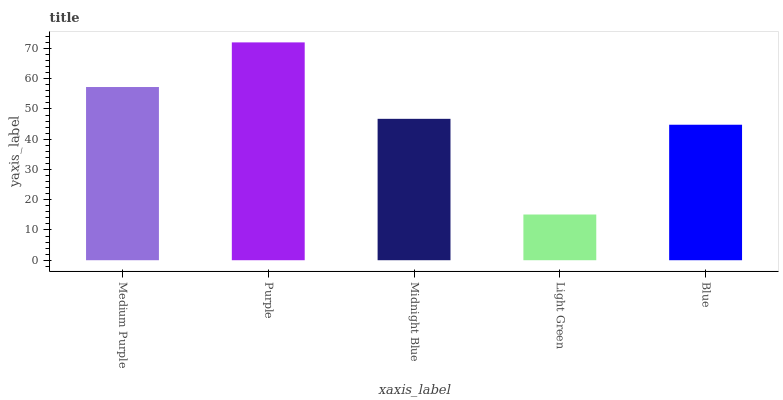Is Light Green the minimum?
Answer yes or no. Yes. Is Purple the maximum?
Answer yes or no. Yes. Is Midnight Blue the minimum?
Answer yes or no. No. Is Midnight Blue the maximum?
Answer yes or no. No. Is Purple greater than Midnight Blue?
Answer yes or no. Yes. Is Midnight Blue less than Purple?
Answer yes or no. Yes. Is Midnight Blue greater than Purple?
Answer yes or no. No. Is Purple less than Midnight Blue?
Answer yes or no. No. Is Midnight Blue the high median?
Answer yes or no. Yes. Is Midnight Blue the low median?
Answer yes or no. Yes. Is Blue the high median?
Answer yes or no. No. Is Medium Purple the low median?
Answer yes or no. No. 